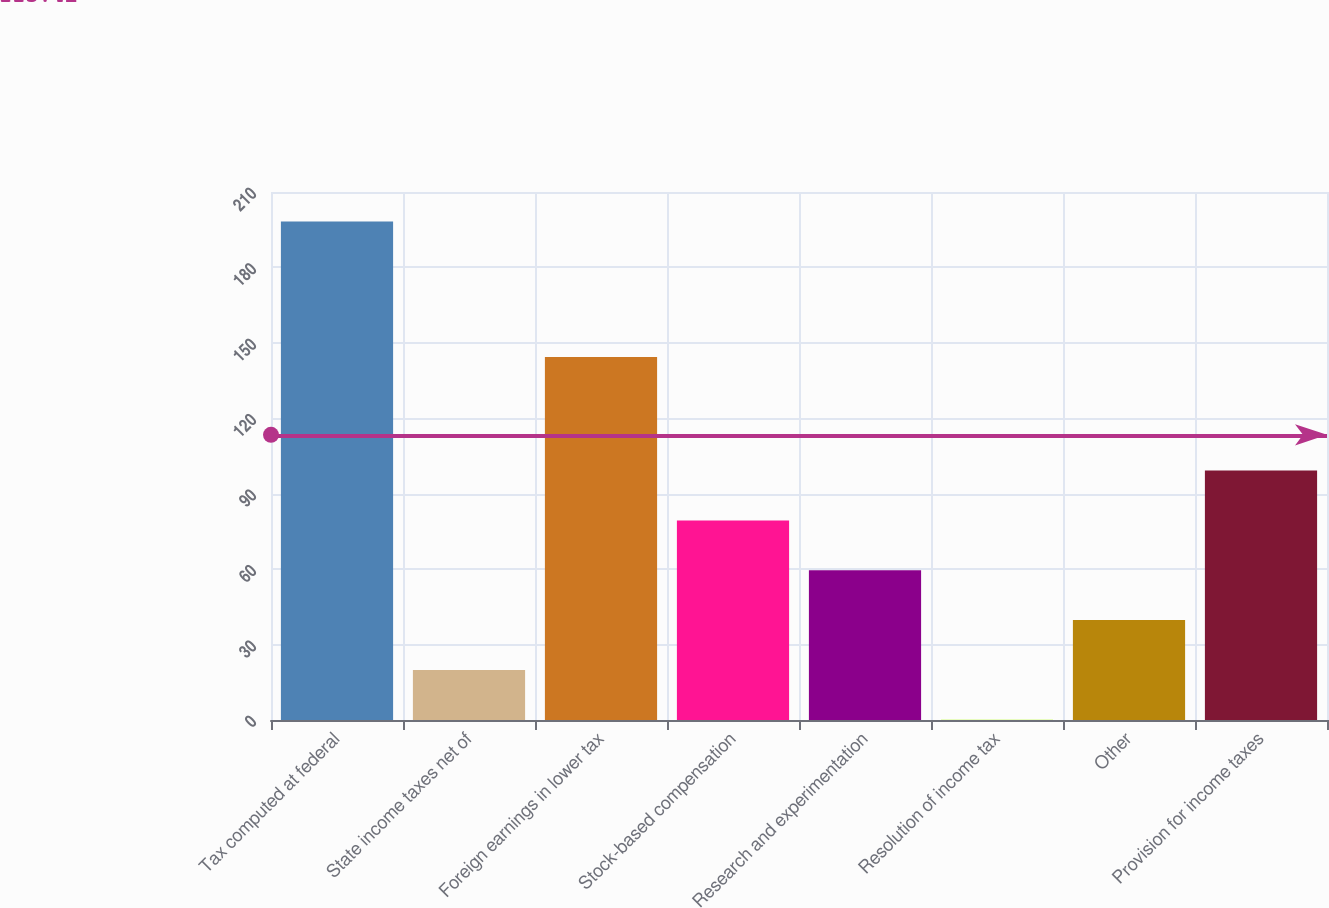Convert chart to OTSL. <chart><loc_0><loc_0><loc_500><loc_500><bar_chart><fcel>Tax computed at federal<fcel>State income taxes net of<fcel>Foreign earnings in lower tax<fcel>Stock-based compensation<fcel>Research and experimentation<fcel>Resolution of income tax<fcel>Other<fcel>Provision for income taxes<nl><fcel>198.3<fcel>19.92<fcel>144.4<fcel>79.38<fcel>59.56<fcel>0.1<fcel>39.74<fcel>99.2<nl></chart> 